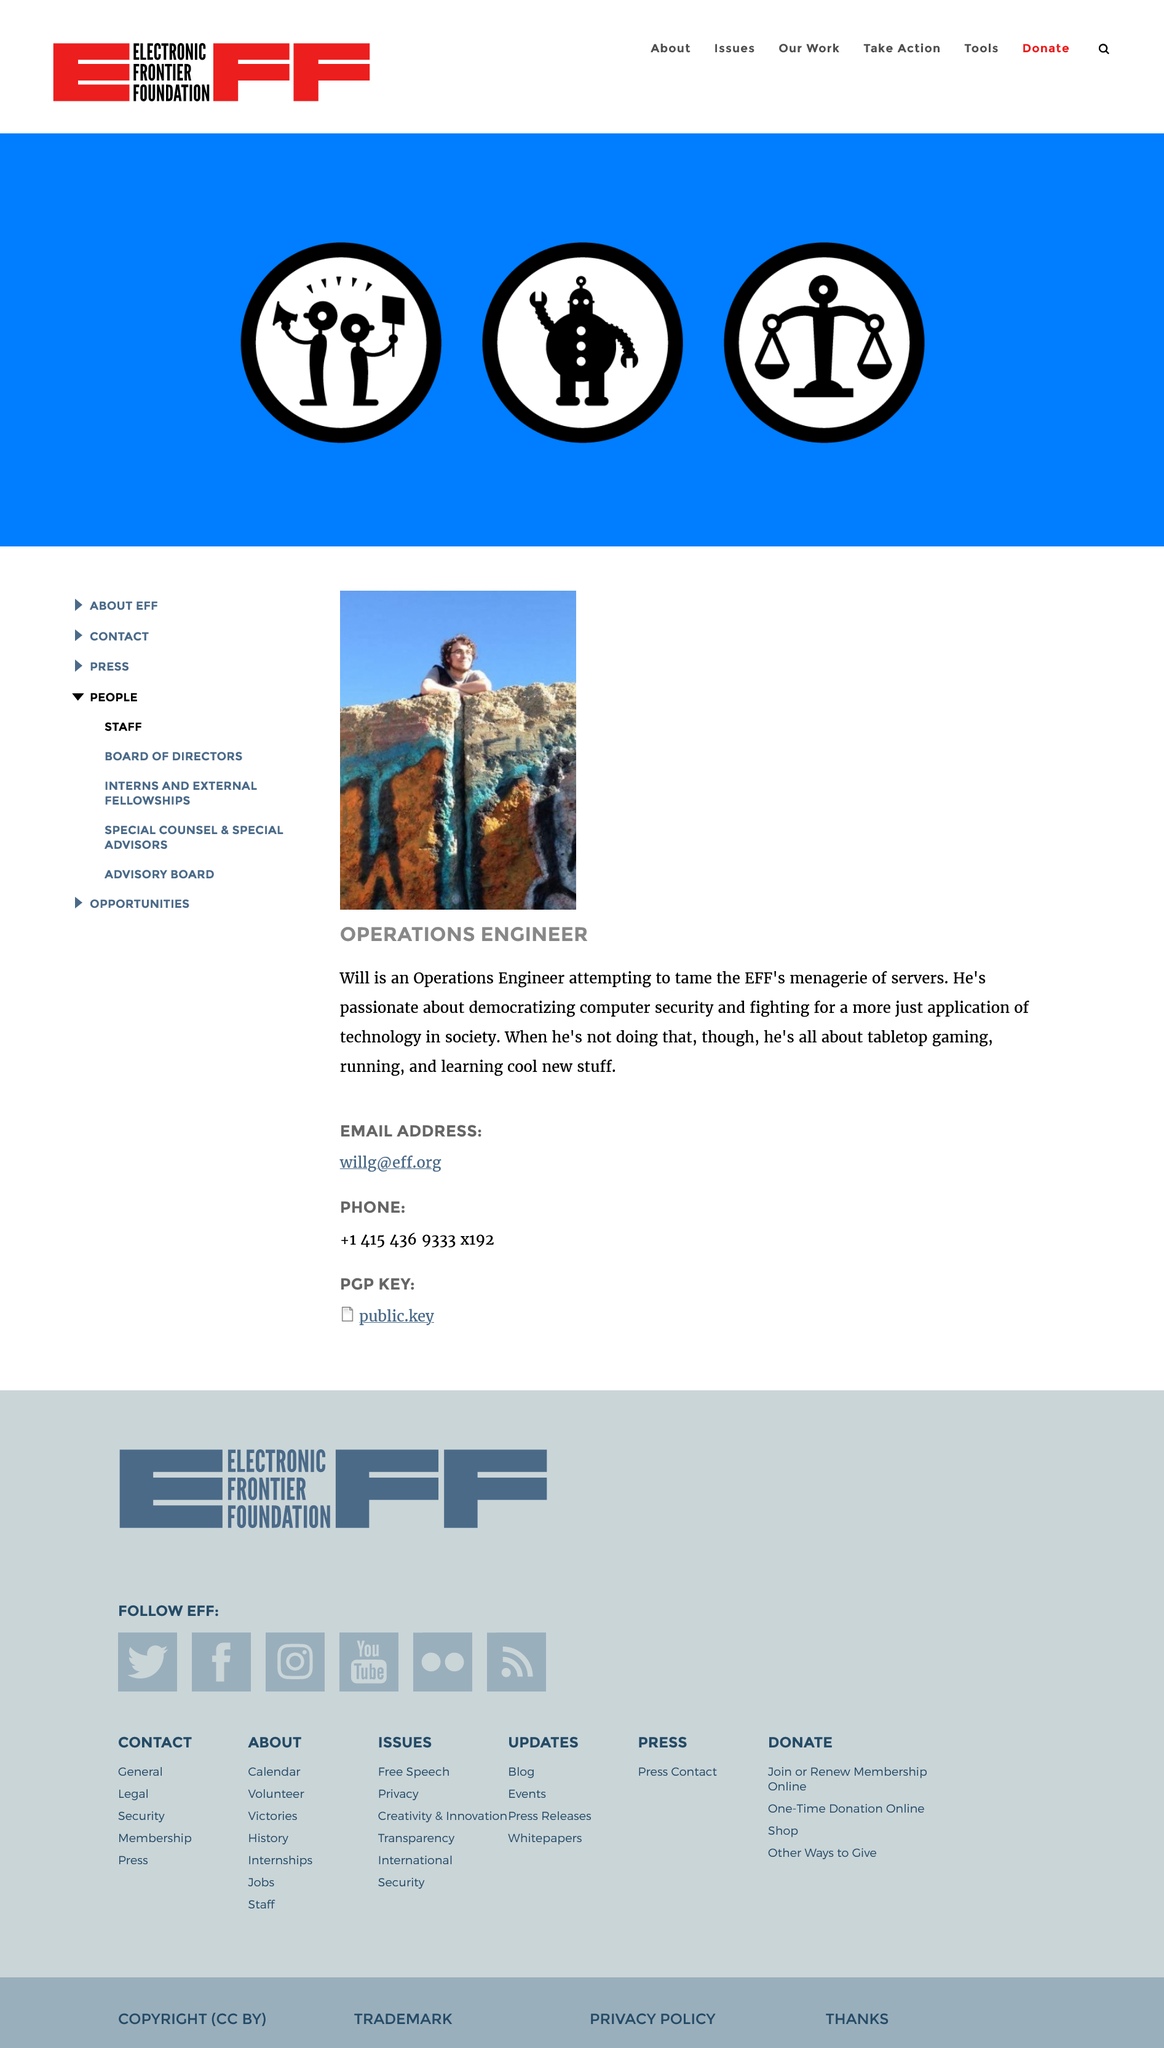Highlight a few significant elements in this photo. Will is passionate about democratizing computer security, which involves making computer security accessible and understandable to a wider audience. Will is an Operations Engineer who holds the job title of 'What.' 